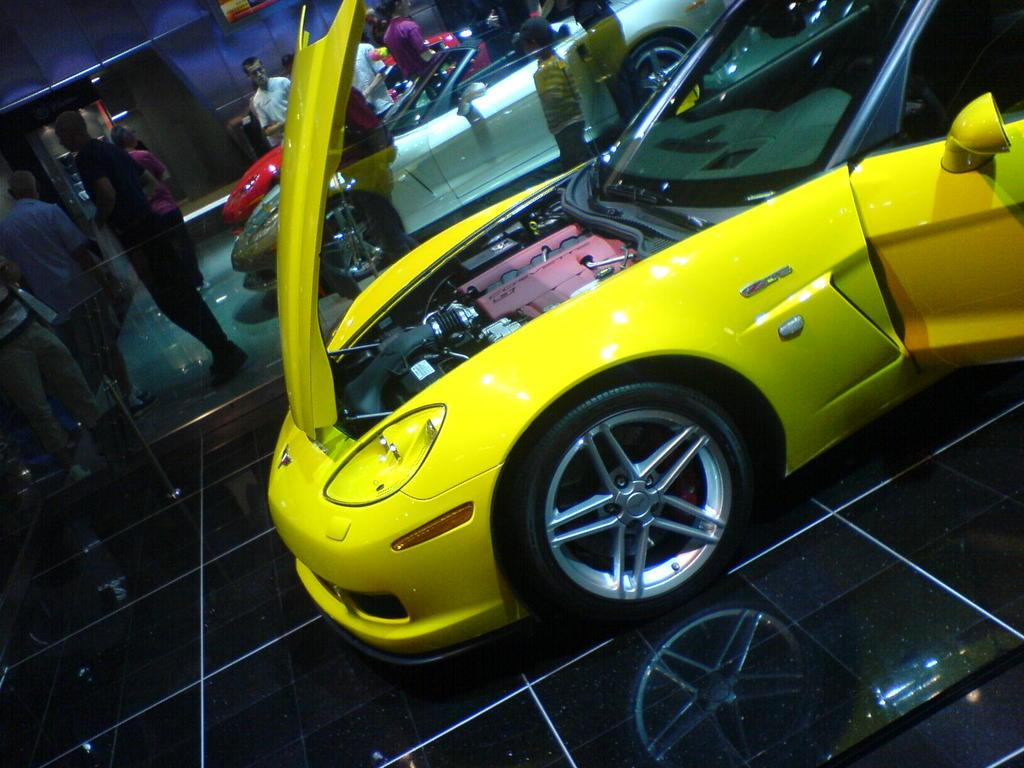What type of vehicles can be seen in the image? There are cars in the image. What are the people in the image doing? There are persons standing on the floor in the image. What can be seen in the background of the image? There is a wall visible in the background of the image. How many eggs are being held by the persons in the image? There are no eggs present in the image; the persons are not holding any eggs. What type of glove is being used by the persons in the image? There are no gloves present in the image; the persons are not wearing or using any gloves. 